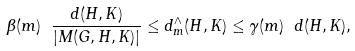Convert formula to latex. <formula><loc_0><loc_0><loc_500><loc_500>\beta ( m ) \ \frac { d ( H , K ) } { | M ( G , H , K ) | } \leq d ^ { \wedge } _ { m } ( H , K ) \leq \gamma ( m ) \ d ( H , K ) ,</formula> 